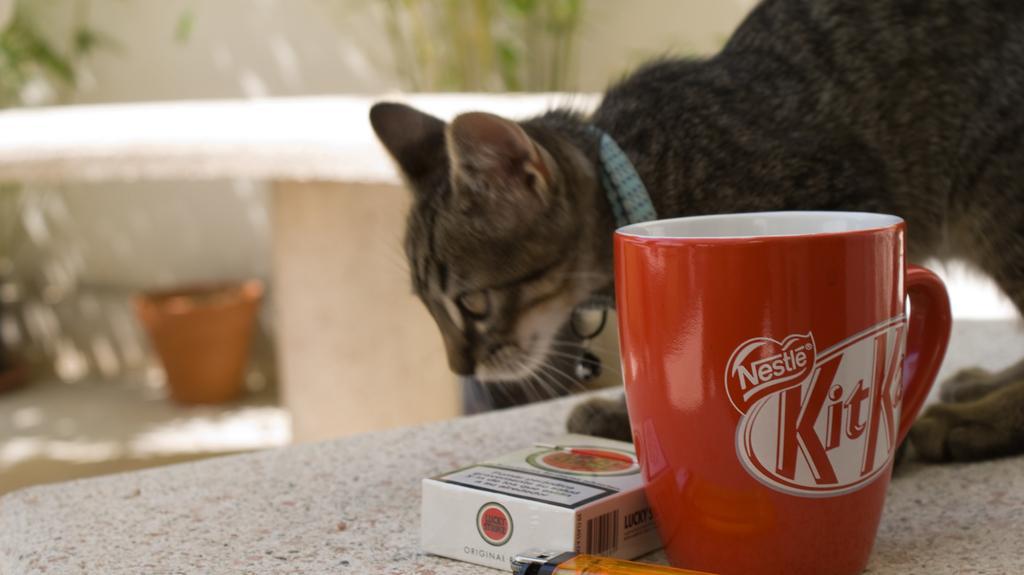In one or two sentences, can you explain what this image depicts? In the picture we can see a cat on the table and beside it, we can see a cup which is red in color with a kit kat label on it and near it we can see the cigarette box and the lighter. In the background, we can see the wall and near it, we can see a part of the plant which is not clearly visible. 